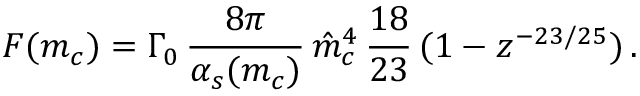<formula> <loc_0><loc_0><loc_500><loc_500>F ( m _ { c } ) = \Gamma _ { 0 } \, { \frac { 8 \pi } { \alpha _ { s } ( m _ { c } ) } } \, \hat { m } _ { c } ^ { 4 } \, { \frac { 1 8 } { 2 3 } } \, ( 1 - z ^ { - 2 3 / 2 5 } ) \, .</formula> 